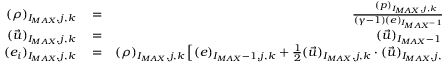<formula> <loc_0><loc_0><loc_500><loc_500>\begin{array} { r l r } { ( \rho ) _ { I _ { M A X } , j , k } } & = } & { \frac { ( p ) _ { I _ { M A X } , j , k } } { ( \gamma - 1 ) ( e ) _ { I _ { M A X } - 1 , j , k } } , } \\ { ( \vec { u } ) _ { I _ { M A X } , j , k } } & = } & { ( \vec { u } ) _ { I _ { M A X } - 1 , j , k } , } \\ { ( e _ { i } ) _ { I _ { M A X } , j , k } } & = } & { ( \rho ) _ { I _ { M A X } , j , k } \left [ ( e ) _ { I _ { M A X } - 1 , j , k } + \frac { 1 } { 2 } ( \vec { u } ) _ { I _ { M A X } , j , k } \cdot ( \vec { u } ) _ { I _ { M A X } , j , k } \right ] \, , } \end{array}</formula> 